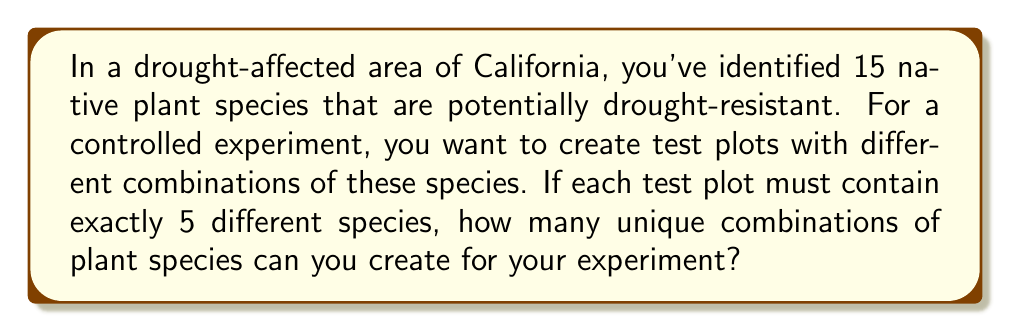Can you solve this math problem? To solve this problem, we need to use the combination formula. We are selecting 5 species from a total of 15 species, where the order doesn't matter (as we're just interested in which species are present, not their arrangement).

The formula for combinations is:

$$ C(n,r) = \frac{n!}{r!(n-r)!} $$

Where:
$n$ is the total number of items to choose from (in this case, 15 plant species)
$r$ is the number of items being chosen (in this case, 5 species per plot)

Plugging in our values:

$$ C(15,5) = \frac{15!}{5!(15-5)!} = \frac{15!}{5!(10)!} $$

Expanding this:

$$ \frac{15 \times 14 \times 13 \times 12 \times 11 \times 10!}{(5 \times 4 \times 3 \times 2 \times 1) \times 10!} $$

The $10!$ cancels out in the numerator and denominator:

$$ \frac{15 \times 14 \times 13 \times 12 \times 11}{5 \times 4 \times 3 \times 2 \times 1} $$

Multiplying the numerator and denominator:

$$ \frac{360,360}{120} = 3,003 $$
Answer: 3,003 unique combinations 